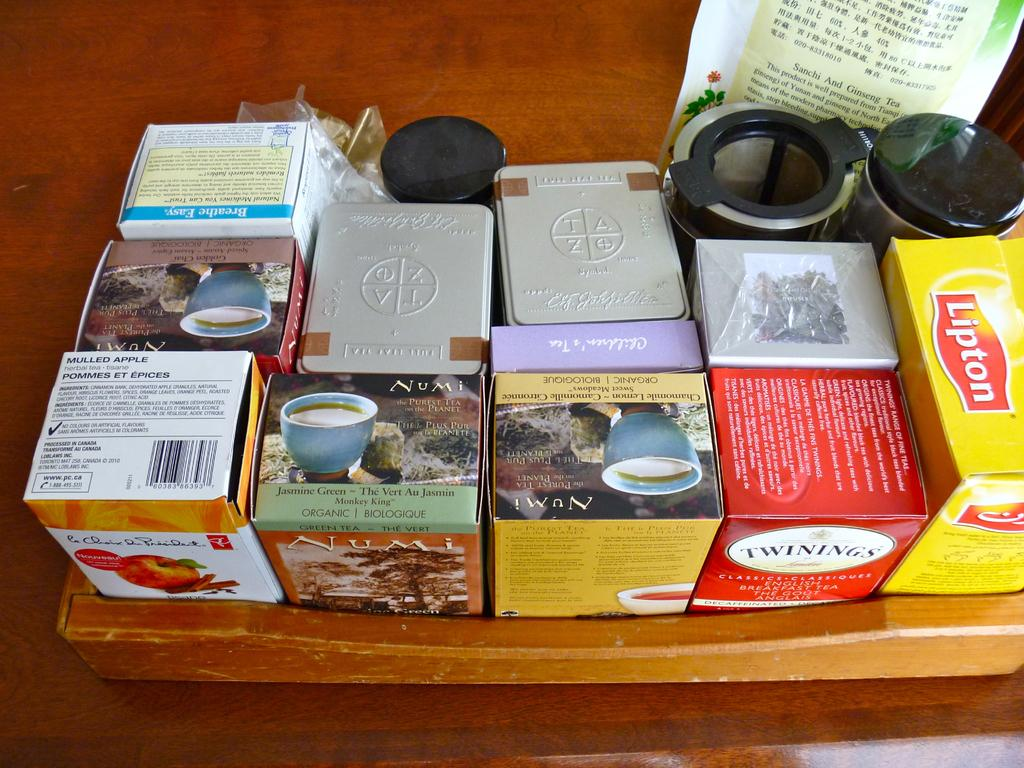<image>
Share a concise interpretation of the image provided. Various boxes of tea on a wooden table including Lipton, Numi and Twinings brands. 